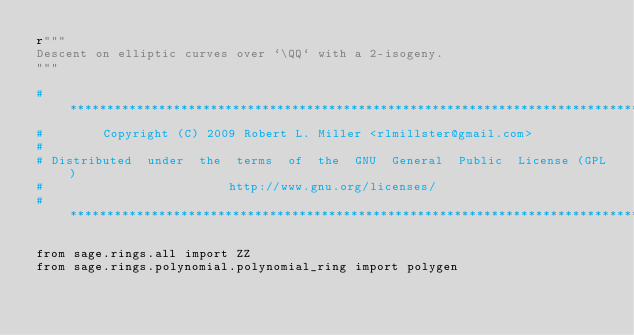Convert code to text. <code><loc_0><loc_0><loc_500><loc_500><_Cython_>r"""
Descent on elliptic curves over `\QQ` with a 2-isogeny.
"""

#*****************************************************************************
#        Copyright (C) 2009 Robert L. Miller <rlmillster@gmail.com>
#
# Distributed  under  the  terms  of  the  GNU  General  Public  License (GPL)
#                         http://www.gnu.org/licenses/
#*****************************************************************************

from sage.rings.all import ZZ
from sage.rings.polynomial.polynomial_ring import polygen</code> 